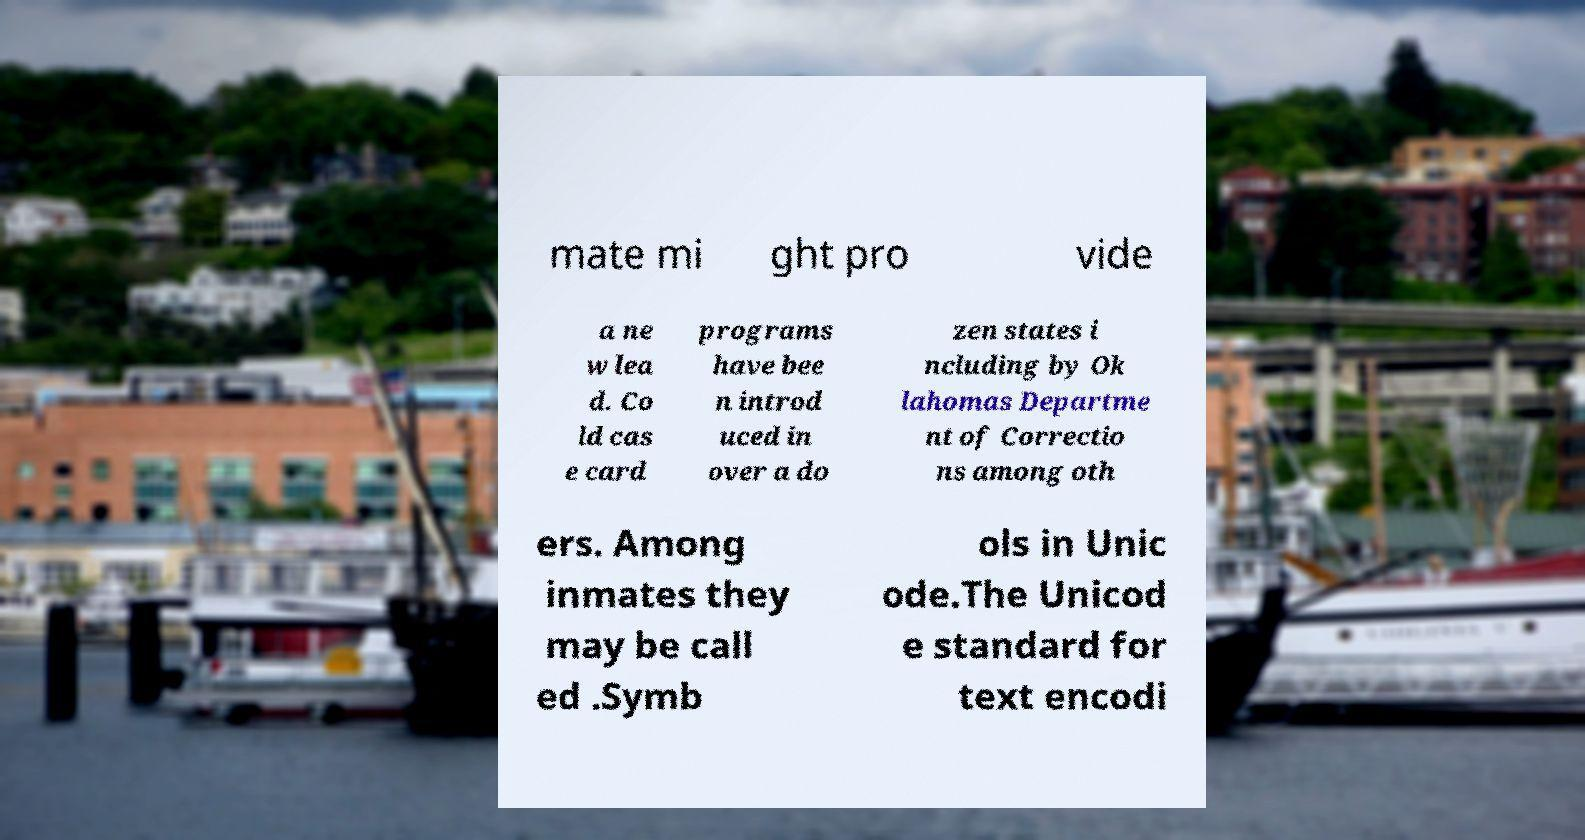What messages or text are displayed in this image? I need them in a readable, typed format. mate mi ght pro vide a ne w lea d. Co ld cas e card programs have bee n introd uced in over a do zen states i ncluding by Ok lahomas Departme nt of Correctio ns among oth ers. Among inmates they may be call ed .Symb ols in Unic ode.The Unicod e standard for text encodi 